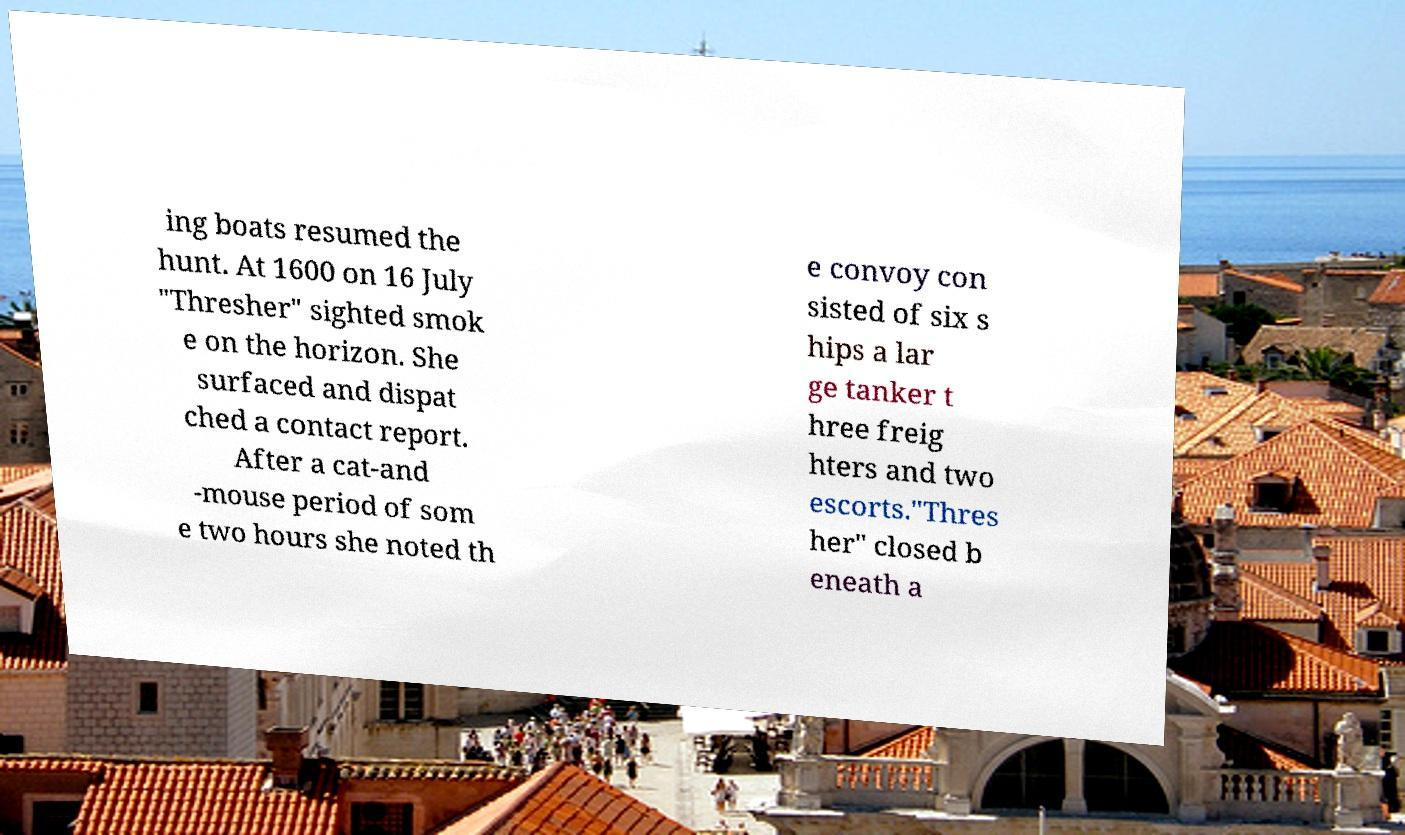I need the written content from this picture converted into text. Can you do that? ing boats resumed the hunt. At 1600 on 16 July "Thresher" sighted smok e on the horizon. She surfaced and dispat ched a contact report. After a cat-and -mouse period of som e two hours she noted th e convoy con sisted of six s hips a lar ge tanker t hree freig hters and two escorts."Thres her" closed b eneath a 